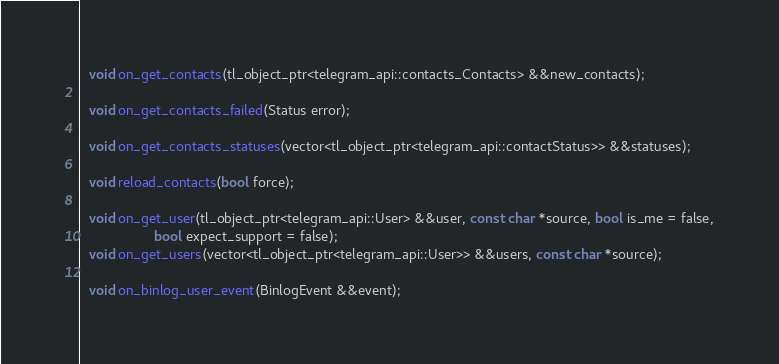Convert code to text. <code><loc_0><loc_0><loc_500><loc_500><_C_>  void on_get_contacts(tl_object_ptr<telegram_api::contacts_Contacts> &&new_contacts);

  void on_get_contacts_failed(Status error);

  void on_get_contacts_statuses(vector<tl_object_ptr<telegram_api::contactStatus>> &&statuses);

  void reload_contacts(bool force);

  void on_get_user(tl_object_ptr<telegram_api::User> &&user, const char *source, bool is_me = false,
                   bool expect_support = false);
  void on_get_users(vector<tl_object_ptr<telegram_api::User>> &&users, const char *source);

  void on_binlog_user_event(BinlogEvent &&event);</code> 